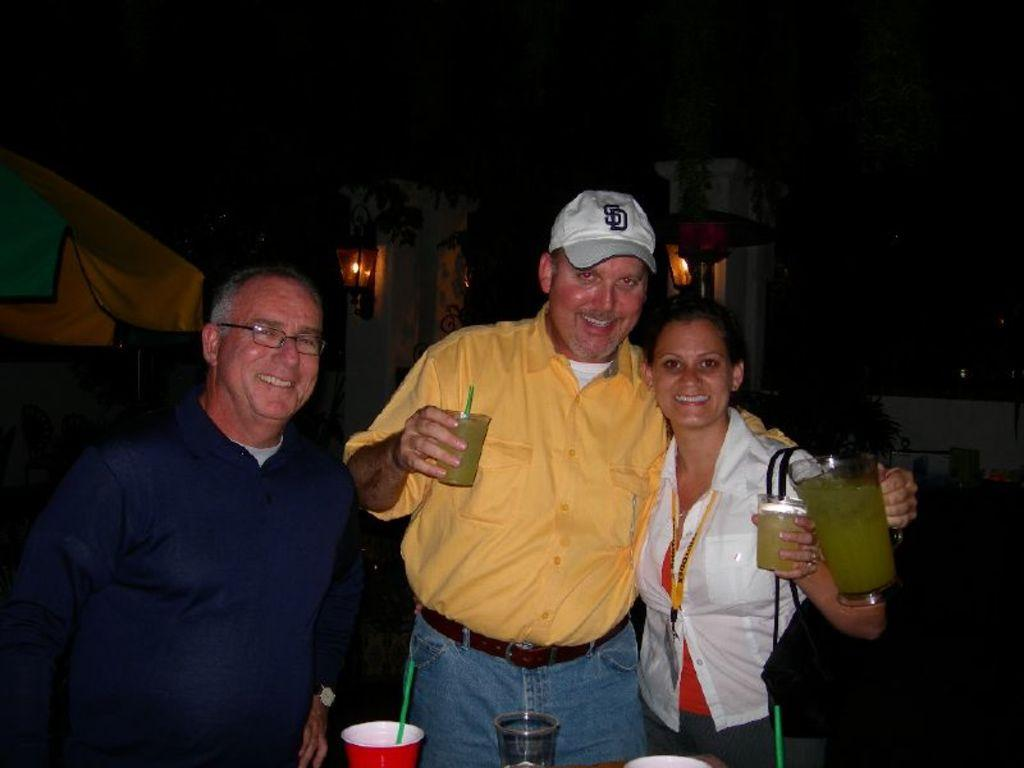<image>
Describe the image concisely. a few people posing for a photo with the man wearing an SD hat 